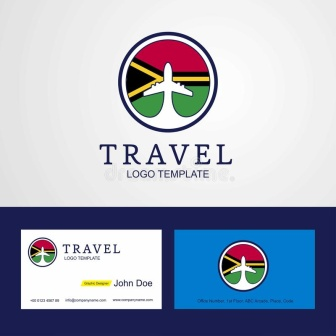What do you think is going on in this snapshot? The image showcases a logo template for a travel company. The logo is a circle with a white background, encased within a vibrant border that is segmented into four colors: red, green, blue, and yellow. The central figure within the circle is a white airplane, leaving behind a yellow trail, and is angled towards the top right corner of the circle. 

Beneath the logo, the word "TRAVEL" is prominently displayed in blue, capitalized letters. A secondary line of text, "LOGO TEMPLATE", is positioned directly under "TRAVEL", presented in a smaller font and a muted gray color.

To the right of the logo, two business cards are displayed. The first business card is horizontally oriented, featuring the logo on the left side and the name "John Doe" on the right. The second business card is vertically oriented, with the logo positioned at the top and the name "John Doe" at the bottom. Both names are written in the same blue color as the word "TRAVEL" in the logo. The business cards appear to be white, matching the background color of the logo. The overall design suggests a clean, modern aesthetic suitable for a contemporary travel company. 